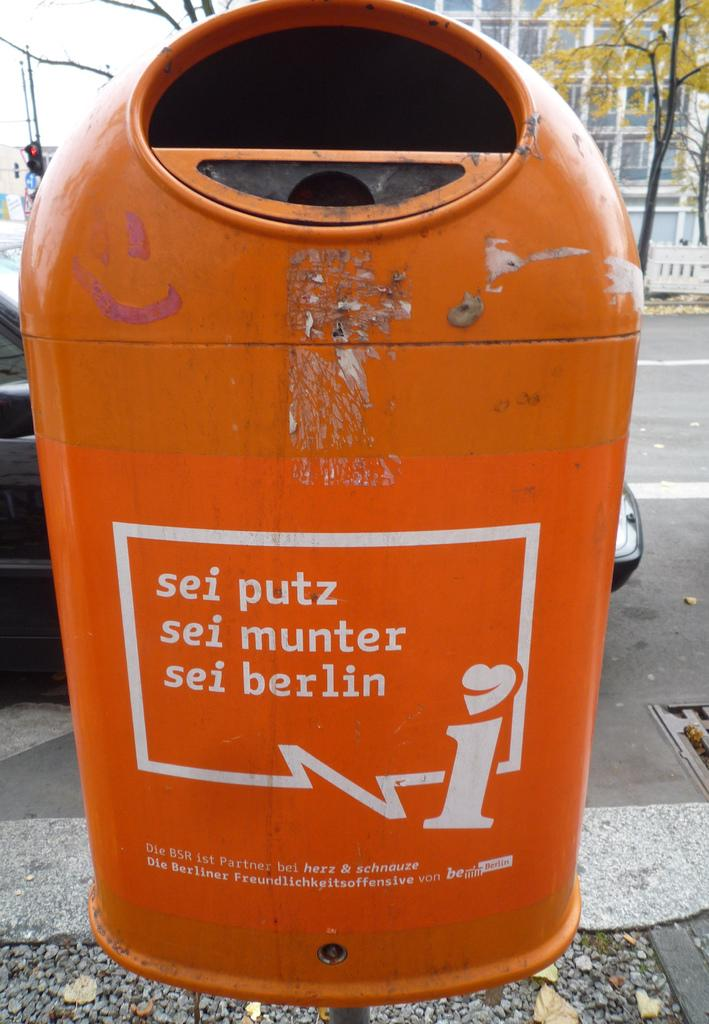<image>
Create a compact narrative representing the image presented. An orange parking meter in Berlin says "sie putz" on it. 